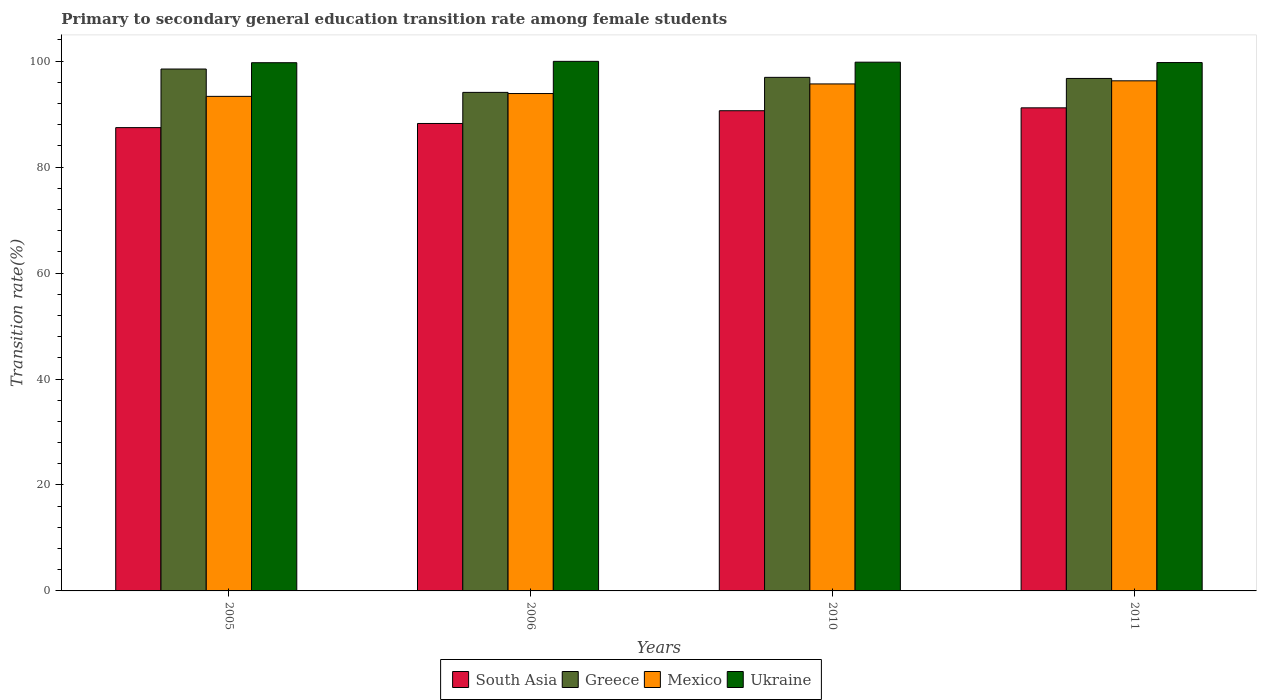How many groups of bars are there?
Provide a succinct answer. 4. Are the number of bars per tick equal to the number of legend labels?
Provide a succinct answer. Yes. Are the number of bars on each tick of the X-axis equal?
Offer a terse response. Yes. How many bars are there on the 1st tick from the right?
Provide a succinct answer. 4. What is the transition rate in Ukraine in 2006?
Your answer should be very brief. 99.97. Across all years, what is the maximum transition rate in Mexico?
Provide a succinct answer. 96.29. Across all years, what is the minimum transition rate in South Asia?
Provide a succinct answer. 87.46. In which year was the transition rate in Ukraine maximum?
Your answer should be very brief. 2006. What is the total transition rate in Mexico in the graph?
Your answer should be very brief. 379.25. What is the difference between the transition rate in South Asia in 2006 and that in 2011?
Make the answer very short. -2.95. What is the difference between the transition rate in Greece in 2005 and the transition rate in South Asia in 2006?
Offer a very short reply. 10.28. What is the average transition rate in South Asia per year?
Give a very brief answer. 89.38. In the year 2005, what is the difference between the transition rate in Greece and transition rate in Ukraine?
Ensure brevity in your answer.  -1.19. What is the ratio of the transition rate in Greece in 2010 to that in 2011?
Offer a terse response. 1. Is the transition rate in Greece in 2006 less than that in 2011?
Offer a very short reply. Yes. Is the difference between the transition rate in Greece in 2006 and 2011 greater than the difference between the transition rate in Ukraine in 2006 and 2011?
Make the answer very short. No. What is the difference between the highest and the second highest transition rate in Mexico?
Your response must be concise. 0.59. What is the difference between the highest and the lowest transition rate in South Asia?
Your answer should be compact. 3.73. Is the sum of the transition rate in Greece in 2006 and 2010 greater than the maximum transition rate in Ukraine across all years?
Keep it short and to the point. Yes. Is it the case that in every year, the sum of the transition rate in South Asia and transition rate in Ukraine is greater than the transition rate in Mexico?
Offer a very short reply. Yes. How many bars are there?
Your answer should be compact. 16. How are the legend labels stacked?
Keep it short and to the point. Horizontal. What is the title of the graph?
Make the answer very short. Primary to secondary general education transition rate among female students. Does "Grenada" appear as one of the legend labels in the graph?
Offer a very short reply. No. What is the label or title of the Y-axis?
Your response must be concise. Transition rate(%). What is the Transition rate(%) of South Asia in 2005?
Offer a very short reply. 87.46. What is the Transition rate(%) of Greece in 2005?
Offer a terse response. 98.52. What is the Transition rate(%) of Mexico in 2005?
Provide a short and direct response. 93.36. What is the Transition rate(%) in Ukraine in 2005?
Your answer should be compact. 99.71. What is the Transition rate(%) of South Asia in 2006?
Provide a short and direct response. 88.24. What is the Transition rate(%) of Greece in 2006?
Your response must be concise. 94.11. What is the Transition rate(%) of Mexico in 2006?
Your response must be concise. 93.89. What is the Transition rate(%) in Ukraine in 2006?
Make the answer very short. 99.97. What is the Transition rate(%) of South Asia in 2010?
Provide a short and direct response. 90.65. What is the Transition rate(%) of Greece in 2010?
Give a very brief answer. 96.95. What is the Transition rate(%) of Mexico in 2010?
Offer a terse response. 95.71. What is the Transition rate(%) of Ukraine in 2010?
Give a very brief answer. 99.81. What is the Transition rate(%) in South Asia in 2011?
Your answer should be compact. 91.19. What is the Transition rate(%) of Greece in 2011?
Provide a short and direct response. 96.74. What is the Transition rate(%) in Mexico in 2011?
Offer a terse response. 96.29. What is the Transition rate(%) in Ukraine in 2011?
Ensure brevity in your answer.  99.74. Across all years, what is the maximum Transition rate(%) in South Asia?
Give a very brief answer. 91.19. Across all years, what is the maximum Transition rate(%) of Greece?
Provide a succinct answer. 98.52. Across all years, what is the maximum Transition rate(%) in Mexico?
Your response must be concise. 96.29. Across all years, what is the maximum Transition rate(%) of Ukraine?
Give a very brief answer. 99.97. Across all years, what is the minimum Transition rate(%) in South Asia?
Provide a succinct answer. 87.46. Across all years, what is the minimum Transition rate(%) of Greece?
Provide a succinct answer. 94.11. Across all years, what is the minimum Transition rate(%) in Mexico?
Ensure brevity in your answer.  93.36. Across all years, what is the minimum Transition rate(%) in Ukraine?
Your answer should be very brief. 99.71. What is the total Transition rate(%) of South Asia in the graph?
Your answer should be compact. 357.54. What is the total Transition rate(%) in Greece in the graph?
Offer a terse response. 386.31. What is the total Transition rate(%) in Mexico in the graph?
Give a very brief answer. 379.25. What is the total Transition rate(%) of Ukraine in the graph?
Keep it short and to the point. 399.23. What is the difference between the Transition rate(%) in South Asia in 2005 and that in 2006?
Ensure brevity in your answer.  -0.78. What is the difference between the Transition rate(%) of Greece in 2005 and that in 2006?
Your answer should be compact. 4.41. What is the difference between the Transition rate(%) of Mexico in 2005 and that in 2006?
Your response must be concise. -0.53. What is the difference between the Transition rate(%) in Ukraine in 2005 and that in 2006?
Give a very brief answer. -0.26. What is the difference between the Transition rate(%) of South Asia in 2005 and that in 2010?
Ensure brevity in your answer.  -3.19. What is the difference between the Transition rate(%) of Greece in 2005 and that in 2010?
Provide a short and direct response. 1.57. What is the difference between the Transition rate(%) of Mexico in 2005 and that in 2010?
Offer a terse response. -2.35. What is the difference between the Transition rate(%) of Ukraine in 2005 and that in 2010?
Your response must be concise. -0.1. What is the difference between the Transition rate(%) of South Asia in 2005 and that in 2011?
Your answer should be compact. -3.73. What is the difference between the Transition rate(%) in Greece in 2005 and that in 2011?
Your response must be concise. 1.78. What is the difference between the Transition rate(%) of Mexico in 2005 and that in 2011?
Your answer should be very brief. -2.94. What is the difference between the Transition rate(%) in Ukraine in 2005 and that in 2011?
Offer a very short reply. -0.03. What is the difference between the Transition rate(%) in South Asia in 2006 and that in 2010?
Keep it short and to the point. -2.41. What is the difference between the Transition rate(%) of Greece in 2006 and that in 2010?
Offer a very short reply. -2.84. What is the difference between the Transition rate(%) of Mexico in 2006 and that in 2010?
Your response must be concise. -1.81. What is the difference between the Transition rate(%) in Ukraine in 2006 and that in 2010?
Your response must be concise. 0.16. What is the difference between the Transition rate(%) of South Asia in 2006 and that in 2011?
Your answer should be compact. -2.95. What is the difference between the Transition rate(%) in Greece in 2006 and that in 2011?
Your answer should be very brief. -2.63. What is the difference between the Transition rate(%) in Mexico in 2006 and that in 2011?
Your answer should be very brief. -2.4. What is the difference between the Transition rate(%) in Ukraine in 2006 and that in 2011?
Your response must be concise. 0.23. What is the difference between the Transition rate(%) of South Asia in 2010 and that in 2011?
Give a very brief answer. -0.54. What is the difference between the Transition rate(%) in Greece in 2010 and that in 2011?
Provide a succinct answer. 0.21. What is the difference between the Transition rate(%) of Mexico in 2010 and that in 2011?
Your response must be concise. -0.59. What is the difference between the Transition rate(%) of Ukraine in 2010 and that in 2011?
Provide a succinct answer. 0.07. What is the difference between the Transition rate(%) of South Asia in 2005 and the Transition rate(%) of Greece in 2006?
Your response must be concise. -6.65. What is the difference between the Transition rate(%) in South Asia in 2005 and the Transition rate(%) in Mexico in 2006?
Provide a short and direct response. -6.44. What is the difference between the Transition rate(%) of South Asia in 2005 and the Transition rate(%) of Ukraine in 2006?
Your answer should be very brief. -12.51. What is the difference between the Transition rate(%) in Greece in 2005 and the Transition rate(%) in Mexico in 2006?
Your response must be concise. 4.63. What is the difference between the Transition rate(%) of Greece in 2005 and the Transition rate(%) of Ukraine in 2006?
Offer a terse response. -1.45. What is the difference between the Transition rate(%) of Mexico in 2005 and the Transition rate(%) of Ukraine in 2006?
Ensure brevity in your answer.  -6.61. What is the difference between the Transition rate(%) in South Asia in 2005 and the Transition rate(%) in Greece in 2010?
Provide a succinct answer. -9.49. What is the difference between the Transition rate(%) of South Asia in 2005 and the Transition rate(%) of Mexico in 2010?
Ensure brevity in your answer.  -8.25. What is the difference between the Transition rate(%) in South Asia in 2005 and the Transition rate(%) in Ukraine in 2010?
Your answer should be compact. -12.35. What is the difference between the Transition rate(%) in Greece in 2005 and the Transition rate(%) in Mexico in 2010?
Give a very brief answer. 2.81. What is the difference between the Transition rate(%) in Greece in 2005 and the Transition rate(%) in Ukraine in 2010?
Your answer should be very brief. -1.29. What is the difference between the Transition rate(%) in Mexico in 2005 and the Transition rate(%) in Ukraine in 2010?
Keep it short and to the point. -6.45. What is the difference between the Transition rate(%) in South Asia in 2005 and the Transition rate(%) in Greece in 2011?
Ensure brevity in your answer.  -9.28. What is the difference between the Transition rate(%) of South Asia in 2005 and the Transition rate(%) of Mexico in 2011?
Provide a succinct answer. -8.84. What is the difference between the Transition rate(%) of South Asia in 2005 and the Transition rate(%) of Ukraine in 2011?
Your answer should be compact. -12.28. What is the difference between the Transition rate(%) in Greece in 2005 and the Transition rate(%) in Mexico in 2011?
Your answer should be compact. 2.23. What is the difference between the Transition rate(%) of Greece in 2005 and the Transition rate(%) of Ukraine in 2011?
Provide a succinct answer. -1.22. What is the difference between the Transition rate(%) of Mexico in 2005 and the Transition rate(%) of Ukraine in 2011?
Give a very brief answer. -6.38. What is the difference between the Transition rate(%) of South Asia in 2006 and the Transition rate(%) of Greece in 2010?
Provide a succinct answer. -8.71. What is the difference between the Transition rate(%) in South Asia in 2006 and the Transition rate(%) in Mexico in 2010?
Provide a succinct answer. -7.47. What is the difference between the Transition rate(%) of South Asia in 2006 and the Transition rate(%) of Ukraine in 2010?
Keep it short and to the point. -11.57. What is the difference between the Transition rate(%) of Greece in 2006 and the Transition rate(%) of Mexico in 2010?
Offer a terse response. -1.6. What is the difference between the Transition rate(%) in Greece in 2006 and the Transition rate(%) in Ukraine in 2010?
Ensure brevity in your answer.  -5.7. What is the difference between the Transition rate(%) in Mexico in 2006 and the Transition rate(%) in Ukraine in 2010?
Offer a very short reply. -5.92. What is the difference between the Transition rate(%) of South Asia in 2006 and the Transition rate(%) of Greece in 2011?
Offer a very short reply. -8.5. What is the difference between the Transition rate(%) of South Asia in 2006 and the Transition rate(%) of Mexico in 2011?
Make the answer very short. -8.05. What is the difference between the Transition rate(%) in South Asia in 2006 and the Transition rate(%) in Ukraine in 2011?
Your answer should be very brief. -11.5. What is the difference between the Transition rate(%) of Greece in 2006 and the Transition rate(%) of Mexico in 2011?
Your response must be concise. -2.18. What is the difference between the Transition rate(%) in Greece in 2006 and the Transition rate(%) in Ukraine in 2011?
Your response must be concise. -5.63. What is the difference between the Transition rate(%) of Mexico in 2006 and the Transition rate(%) of Ukraine in 2011?
Ensure brevity in your answer.  -5.85. What is the difference between the Transition rate(%) of South Asia in 2010 and the Transition rate(%) of Greece in 2011?
Keep it short and to the point. -6.09. What is the difference between the Transition rate(%) in South Asia in 2010 and the Transition rate(%) in Mexico in 2011?
Your response must be concise. -5.65. What is the difference between the Transition rate(%) in South Asia in 2010 and the Transition rate(%) in Ukraine in 2011?
Make the answer very short. -9.09. What is the difference between the Transition rate(%) in Greece in 2010 and the Transition rate(%) in Mexico in 2011?
Offer a very short reply. 0.65. What is the difference between the Transition rate(%) in Greece in 2010 and the Transition rate(%) in Ukraine in 2011?
Give a very brief answer. -2.79. What is the difference between the Transition rate(%) in Mexico in 2010 and the Transition rate(%) in Ukraine in 2011?
Provide a succinct answer. -4.03. What is the average Transition rate(%) in South Asia per year?
Offer a very short reply. 89.38. What is the average Transition rate(%) of Greece per year?
Provide a short and direct response. 96.58. What is the average Transition rate(%) of Mexico per year?
Offer a very short reply. 94.81. What is the average Transition rate(%) of Ukraine per year?
Offer a very short reply. 99.81. In the year 2005, what is the difference between the Transition rate(%) in South Asia and Transition rate(%) in Greece?
Your answer should be very brief. -11.06. In the year 2005, what is the difference between the Transition rate(%) in South Asia and Transition rate(%) in Mexico?
Your answer should be compact. -5.9. In the year 2005, what is the difference between the Transition rate(%) of South Asia and Transition rate(%) of Ukraine?
Offer a terse response. -12.25. In the year 2005, what is the difference between the Transition rate(%) in Greece and Transition rate(%) in Mexico?
Give a very brief answer. 5.16. In the year 2005, what is the difference between the Transition rate(%) of Greece and Transition rate(%) of Ukraine?
Ensure brevity in your answer.  -1.19. In the year 2005, what is the difference between the Transition rate(%) in Mexico and Transition rate(%) in Ukraine?
Your response must be concise. -6.35. In the year 2006, what is the difference between the Transition rate(%) in South Asia and Transition rate(%) in Greece?
Offer a terse response. -5.87. In the year 2006, what is the difference between the Transition rate(%) of South Asia and Transition rate(%) of Mexico?
Offer a very short reply. -5.65. In the year 2006, what is the difference between the Transition rate(%) in South Asia and Transition rate(%) in Ukraine?
Provide a succinct answer. -11.73. In the year 2006, what is the difference between the Transition rate(%) of Greece and Transition rate(%) of Mexico?
Your answer should be compact. 0.22. In the year 2006, what is the difference between the Transition rate(%) in Greece and Transition rate(%) in Ukraine?
Provide a succinct answer. -5.86. In the year 2006, what is the difference between the Transition rate(%) of Mexico and Transition rate(%) of Ukraine?
Make the answer very short. -6.07. In the year 2010, what is the difference between the Transition rate(%) of South Asia and Transition rate(%) of Greece?
Provide a succinct answer. -6.3. In the year 2010, what is the difference between the Transition rate(%) of South Asia and Transition rate(%) of Mexico?
Provide a succinct answer. -5.06. In the year 2010, what is the difference between the Transition rate(%) of South Asia and Transition rate(%) of Ukraine?
Your answer should be compact. -9.16. In the year 2010, what is the difference between the Transition rate(%) in Greece and Transition rate(%) in Mexico?
Keep it short and to the point. 1.24. In the year 2010, what is the difference between the Transition rate(%) in Greece and Transition rate(%) in Ukraine?
Provide a short and direct response. -2.86. In the year 2010, what is the difference between the Transition rate(%) in Mexico and Transition rate(%) in Ukraine?
Your answer should be very brief. -4.1. In the year 2011, what is the difference between the Transition rate(%) of South Asia and Transition rate(%) of Greece?
Make the answer very short. -5.55. In the year 2011, what is the difference between the Transition rate(%) of South Asia and Transition rate(%) of Mexico?
Your answer should be compact. -5.1. In the year 2011, what is the difference between the Transition rate(%) in South Asia and Transition rate(%) in Ukraine?
Provide a short and direct response. -8.55. In the year 2011, what is the difference between the Transition rate(%) of Greece and Transition rate(%) of Mexico?
Ensure brevity in your answer.  0.45. In the year 2011, what is the difference between the Transition rate(%) in Greece and Transition rate(%) in Ukraine?
Provide a succinct answer. -3. In the year 2011, what is the difference between the Transition rate(%) of Mexico and Transition rate(%) of Ukraine?
Your answer should be compact. -3.45. What is the ratio of the Transition rate(%) in South Asia in 2005 to that in 2006?
Provide a succinct answer. 0.99. What is the ratio of the Transition rate(%) in Greece in 2005 to that in 2006?
Provide a short and direct response. 1.05. What is the ratio of the Transition rate(%) in South Asia in 2005 to that in 2010?
Keep it short and to the point. 0.96. What is the ratio of the Transition rate(%) in Greece in 2005 to that in 2010?
Your answer should be compact. 1.02. What is the ratio of the Transition rate(%) in Mexico in 2005 to that in 2010?
Your answer should be very brief. 0.98. What is the ratio of the Transition rate(%) in Ukraine in 2005 to that in 2010?
Make the answer very short. 1. What is the ratio of the Transition rate(%) of South Asia in 2005 to that in 2011?
Ensure brevity in your answer.  0.96. What is the ratio of the Transition rate(%) of Greece in 2005 to that in 2011?
Make the answer very short. 1.02. What is the ratio of the Transition rate(%) of Mexico in 2005 to that in 2011?
Ensure brevity in your answer.  0.97. What is the ratio of the Transition rate(%) of Ukraine in 2005 to that in 2011?
Keep it short and to the point. 1. What is the ratio of the Transition rate(%) of South Asia in 2006 to that in 2010?
Keep it short and to the point. 0.97. What is the ratio of the Transition rate(%) in Greece in 2006 to that in 2010?
Offer a very short reply. 0.97. What is the ratio of the Transition rate(%) of Mexico in 2006 to that in 2010?
Your answer should be very brief. 0.98. What is the ratio of the Transition rate(%) in South Asia in 2006 to that in 2011?
Provide a succinct answer. 0.97. What is the ratio of the Transition rate(%) in Greece in 2006 to that in 2011?
Offer a terse response. 0.97. What is the ratio of the Transition rate(%) of Mexico in 2006 to that in 2011?
Provide a short and direct response. 0.98. What is the ratio of the Transition rate(%) in South Asia in 2010 to that in 2011?
Give a very brief answer. 0.99. What is the ratio of the Transition rate(%) of Ukraine in 2010 to that in 2011?
Make the answer very short. 1. What is the difference between the highest and the second highest Transition rate(%) in South Asia?
Ensure brevity in your answer.  0.54. What is the difference between the highest and the second highest Transition rate(%) of Greece?
Your response must be concise. 1.57. What is the difference between the highest and the second highest Transition rate(%) of Mexico?
Provide a succinct answer. 0.59. What is the difference between the highest and the second highest Transition rate(%) in Ukraine?
Offer a terse response. 0.16. What is the difference between the highest and the lowest Transition rate(%) in South Asia?
Make the answer very short. 3.73. What is the difference between the highest and the lowest Transition rate(%) in Greece?
Make the answer very short. 4.41. What is the difference between the highest and the lowest Transition rate(%) of Mexico?
Give a very brief answer. 2.94. What is the difference between the highest and the lowest Transition rate(%) of Ukraine?
Make the answer very short. 0.26. 